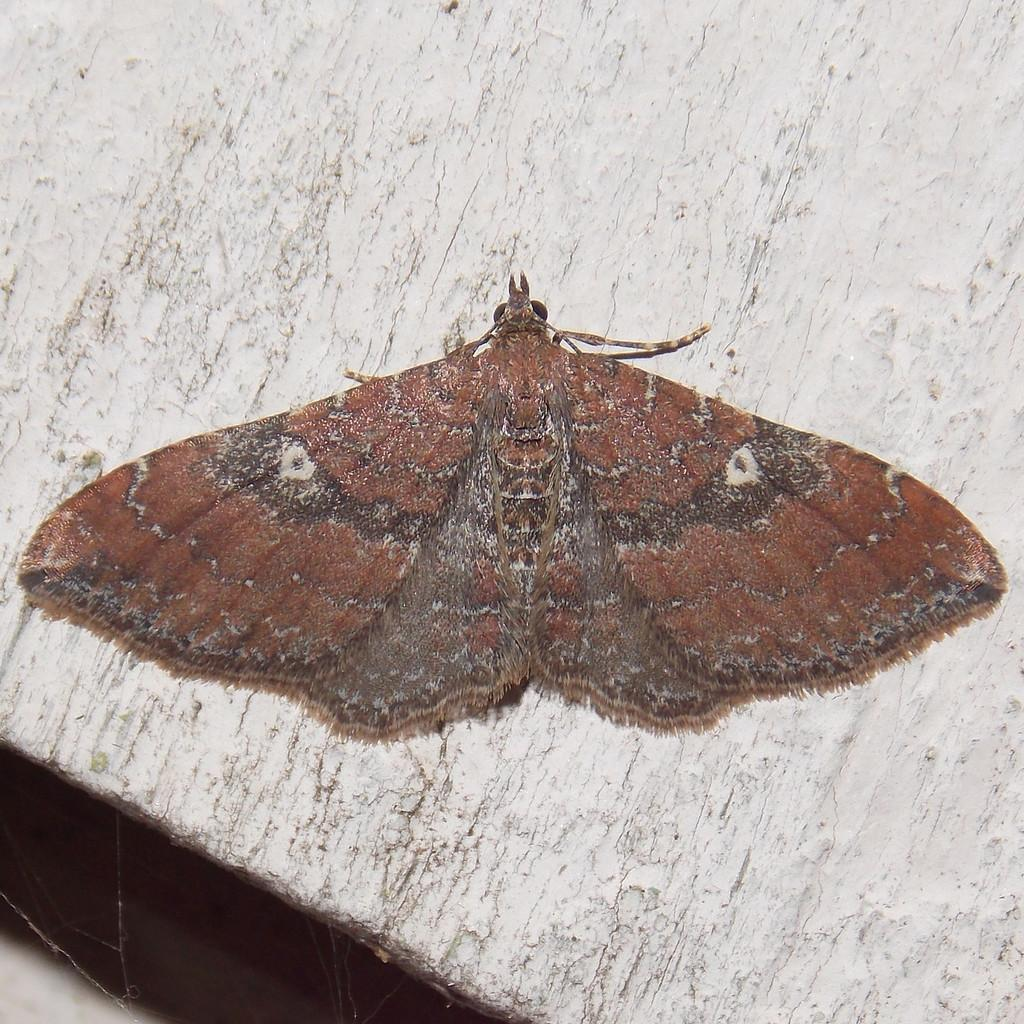What is the main subject of the image? There is a butterfly in the image. Can you describe the color of the butterfly? The butterfly is brown in color. Where is the butterfly located in the image? The butterfly is on the wall. What type of quilt is being used by the tramp in the image? There is no tramp or quilt present in the image; it features a brown butterfly on the wall. Is the chair in the image made of wood or metal? There is no chair present in the image. 